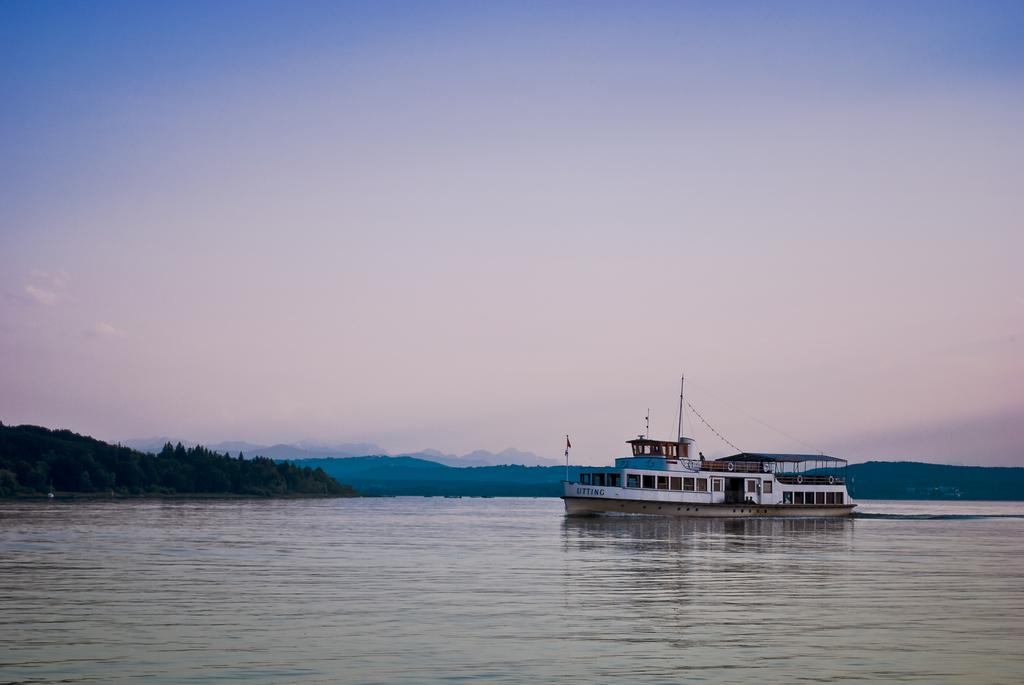What is the main subject of the image? The main subject of the image is a ship. Where is the ship located? The ship is on a lake. What other natural elements can be seen in the image? There are trees and a hill visible in the image. What is visible at the top of the image? The sky is visible at the top of the image. How many grapes are hanging from the trees in the image? There are no grapes visible in the image; the trees are not mentioned as having grapes. What effect does the ship have on the trees in the image? There is no indication in the image that the ship has any effect on the trees. 